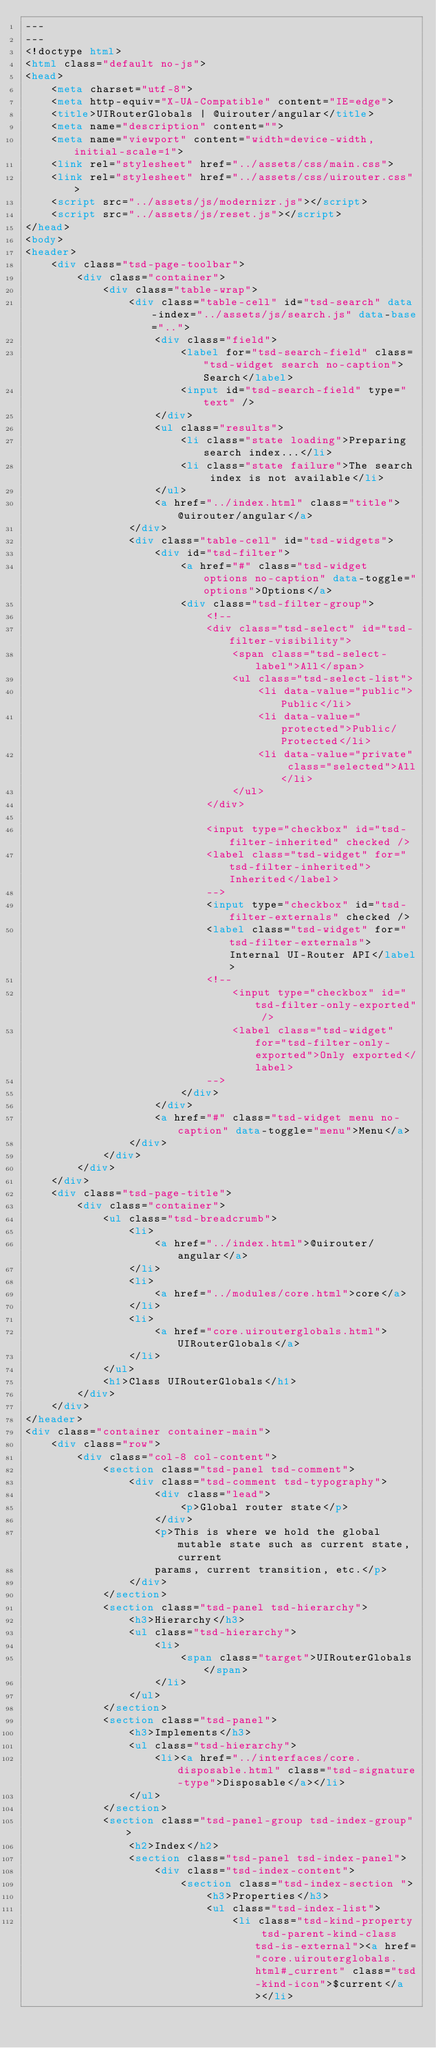<code> <loc_0><loc_0><loc_500><loc_500><_HTML_>---
---
<!doctype html>
<html class="default no-js">
<head>
	<meta charset="utf-8">
	<meta http-equiv="X-UA-Compatible" content="IE=edge">
	<title>UIRouterGlobals | @uirouter/angular</title>
	<meta name="description" content="">
	<meta name="viewport" content="width=device-width, initial-scale=1">
	<link rel="stylesheet" href="../assets/css/main.css">
	<link rel="stylesheet" href="../assets/css/uirouter.css">
	<script src="../assets/js/modernizr.js"></script>
	<script src="../assets/js/reset.js"></script>
</head>
<body>
<header>
	<div class="tsd-page-toolbar">
		<div class="container">
			<div class="table-wrap">
				<div class="table-cell" id="tsd-search" data-index="../assets/js/search.js" data-base="..">
					<div class="field">
						<label for="tsd-search-field" class="tsd-widget search no-caption">Search</label>
						<input id="tsd-search-field" type="text" />
					</div>
					<ul class="results">
						<li class="state loading">Preparing search index...</li>
						<li class="state failure">The search index is not available</li>
					</ul>
					<a href="../index.html" class="title">@uirouter/angular</a>
				</div>
				<div class="table-cell" id="tsd-widgets">
					<div id="tsd-filter">
						<a href="#" class="tsd-widget options no-caption" data-toggle="options">Options</a>
						<div class="tsd-filter-group">
							<!--
                            <div class="tsd-select" id="tsd-filter-visibility">
                                <span class="tsd-select-label">All</span>
                                <ul class="tsd-select-list">
                                    <li data-value="public">Public</li>
                                    <li data-value="protected">Public/Protected</li>
                                    <li data-value="private" class="selected">All</li>
                                </ul>
                            </div>

                            <input type="checkbox" id="tsd-filter-inherited" checked />
                            <label class="tsd-widget" for="tsd-filter-inherited">Inherited</label>
                            -->
							<input type="checkbox" id="tsd-filter-externals" checked />
							<label class="tsd-widget" for="tsd-filter-externals">Internal UI-Router API</label>
							<!--
                                <input type="checkbox" id="tsd-filter-only-exported" />
                                <label class="tsd-widget" for="tsd-filter-only-exported">Only exported</label>
                            -->
						</div>
					</div>
					<a href="#" class="tsd-widget menu no-caption" data-toggle="menu">Menu</a>
				</div>
			</div>
		</div>
	</div>
	<div class="tsd-page-title">
		<div class="container">
			<ul class="tsd-breadcrumb">
				<li>
					<a href="../index.html">@uirouter/angular</a>
				</li>
				<li>
					<a href="../modules/core.html">core</a>
				</li>
				<li>
					<a href="core.uirouterglobals.html">UIRouterGlobals</a>
				</li>
			</ul>
			<h1>Class UIRouterGlobals</h1>
		</div>
	</div>
</header>
<div class="container container-main">
	<div class="row">
		<div class="col-8 col-content">
			<section class="tsd-panel tsd-comment">
				<div class="tsd-comment tsd-typography">
					<div class="lead">
						<p>Global router state</p>
					</div>
					<p>This is where we hold the global mutable state such as current state, current
					params, current transition, etc.</p>
				</div>
			</section>
			<section class="tsd-panel tsd-hierarchy">
				<h3>Hierarchy</h3>
				<ul class="tsd-hierarchy">
					<li>
						<span class="target">UIRouterGlobals</span>
					</li>
				</ul>
			</section>
			<section class="tsd-panel">
				<h3>Implements</h3>
				<ul class="tsd-hierarchy">
					<li><a href="../interfaces/core.disposable.html" class="tsd-signature-type">Disposable</a></li>
				</ul>
			</section>
			<section class="tsd-panel-group tsd-index-group">
				<h2>Index</h2>
				<section class="tsd-panel tsd-index-panel">
					<div class="tsd-index-content">
						<section class="tsd-index-section ">
							<h3>Properties</h3>
							<ul class="tsd-index-list">
								<li class="tsd-kind-property tsd-parent-kind-class tsd-is-external"><a href="core.uirouterglobals.html#_current" class="tsd-kind-icon">$current</a></li></code> 